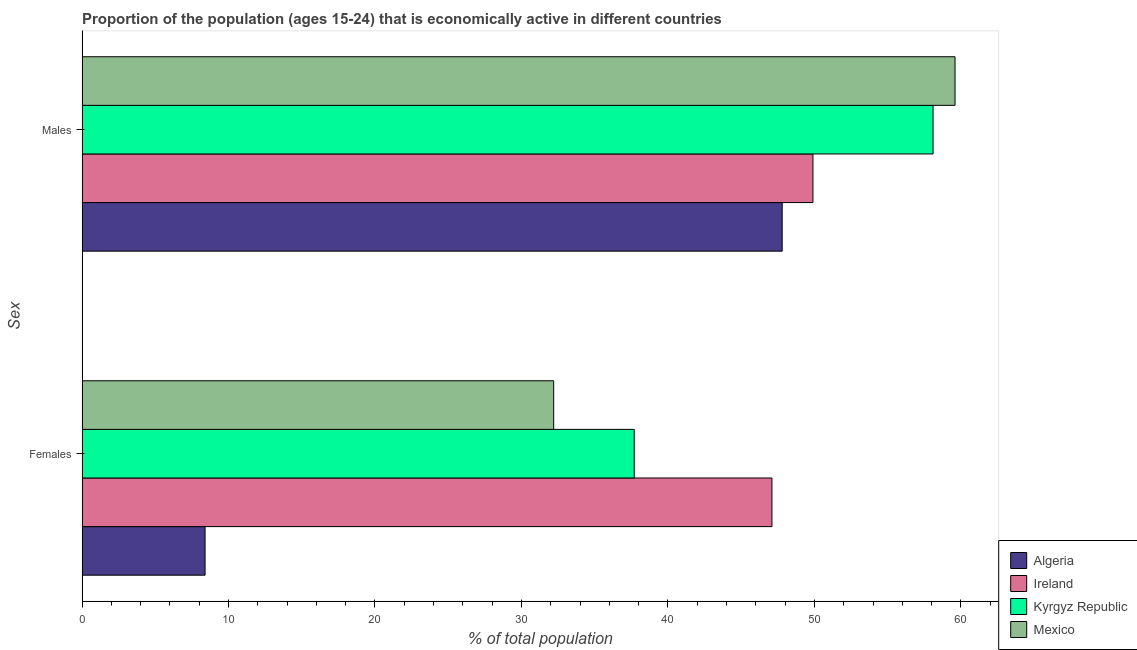How many different coloured bars are there?
Your answer should be very brief. 4. How many groups of bars are there?
Your answer should be compact. 2. Are the number of bars per tick equal to the number of legend labels?
Ensure brevity in your answer.  Yes. Are the number of bars on each tick of the Y-axis equal?
Ensure brevity in your answer.  Yes. How many bars are there on the 1st tick from the bottom?
Provide a short and direct response. 4. What is the label of the 1st group of bars from the top?
Give a very brief answer. Males. What is the percentage of economically active male population in Mexico?
Provide a succinct answer. 59.6. Across all countries, what is the maximum percentage of economically active male population?
Your answer should be compact. 59.6. Across all countries, what is the minimum percentage of economically active male population?
Give a very brief answer. 47.8. In which country was the percentage of economically active male population maximum?
Give a very brief answer. Mexico. In which country was the percentage of economically active female population minimum?
Provide a short and direct response. Algeria. What is the total percentage of economically active female population in the graph?
Offer a very short reply. 125.4. What is the difference between the percentage of economically active female population in Algeria and the percentage of economically active male population in Mexico?
Your answer should be very brief. -51.2. What is the average percentage of economically active female population per country?
Offer a terse response. 31.35. What is the difference between the percentage of economically active female population and percentage of economically active male population in Ireland?
Keep it short and to the point. -2.8. What is the ratio of the percentage of economically active male population in Ireland to that in Kyrgyz Republic?
Keep it short and to the point. 0.86. Is the percentage of economically active female population in Ireland less than that in Algeria?
Provide a short and direct response. No. In how many countries, is the percentage of economically active male population greater than the average percentage of economically active male population taken over all countries?
Ensure brevity in your answer.  2. What does the 4th bar from the top in Males represents?
Keep it short and to the point. Algeria. What does the 3rd bar from the bottom in Females represents?
Give a very brief answer. Kyrgyz Republic. How many bars are there?
Your answer should be compact. 8. Are all the bars in the graph horizontal?
Make the answer very short. Yes. How many countries are there in the graph?
Provide a succinct answer. 4. What is the difference between two consecutive major ticks on the X-axis?
Give a very brief answer. 10. Are the values on the major ticks of X-axis written in scientific E-notation?
Your answer should be very brief. No. Does the graph contain any zero values?
Your answer should be compact. No. Does the graph contain grids?
Your response must be concise. No. How many legend labels are there?
Your answer should be very brief. 4. How are the legend labels stacked?
Keep it short and to the point. Vertical. What is the title of the graph?
Provide a short and direct response. Proportion of the population (ages 15-24) that is economically active in different countries. What is the label or title of the X-axis?
Keep it short and to the point. % of total population. What is the label or title of the Y-axis?
Offer a terse response. Sex. What is the % of total population of Algeria in Females?
Give a very brief answer. 8.4. What is the % of total population of Ireland in Females?
Ensure brevity in your answer.  47.1. What is the % of total population of Kyrgyz Republic in Females?
Make the answer very short. 37.7. What is the % of total population of Mexico in Females?
Offer a terse response. 32.2. What is the % of total population in Algeria in Males?
Provide a succinct answer. 47.8. What is the % of total population in Ireland in Males?
Your answer should be very brief. 49.9. What is the % of total population of Kyrgyz Republic in Males?
Make the answer very short. 58.1. What is the % of total population in Mexico in Males?
Your answer should be very brief. 59.6. Across all Sex, what is the maximum % of total population of Algeria?
Provide a short and direct response. 47.8. Across all Sex, what is the maximum % of total population of Ireland?
Provide a succinct answer. 49.9. Across all Sex, what is the maximum % of total population of Kyrgyz Republic?
Your response must be concise. 58.1. Across all Sex, what is the maximum % of total population of Mexico?
Provide a short and direct response. 59.6. Across all Sex, what is the minimum % of total population of Algeria?
Your response must be concise. 8.4. Across all Sex, what is the minimum % of total population in Ireland?
Make the answer very short. 47.1. Across all Sex, what is the minimum % of total population of Kyrgyz Republic?
Offer a very short reply. 37.7. Across all Sex, what is the minimum % of total population in Mexico?
Make the answer very short. 32.2. What is the total % of total population of Algeria in the graph?
Keep it short and to the point. 56.2. What is the total % of total population in Ireland in the graph?
Provide a succinct answer. 97. What is the total % of total population of Kyrgyz Republic in the graph?
Ensure brevity in your answer.  95.8. What is the total % of total population of Mexico in the graph?
Make the answer very short. 91.8. What is the difference between the % of total population of Algeria in Females and that in Males?
Your response must be concise. -39.4. What is the difference between the % of total population of Ireland in Females and that in Males?
Your response must be concise. -2.8. What is the difference between the % of total population of Kyrgyz Republic in Females and that in Males?
Make the answer very short. -20.4. What is the difference between the % of total population of Mexico in Females and that in Males?
Your answer should be compact. -27.4. What is the difference between the % of total population in Algeria in Females and the % of total population in Ireland in Males?
Your answer should be compact. -41.5. What is the difference between the % of total population of Algeria in Females and the % of total population of Kyrgyz Republic in Males?
Offer a terse response. -49.7. What is the difference between the % of total population in Algeria in Females and the % of total population in Mexico in Males?
Your answer should be compact. -51.2. What is the difference between the % of total population in Ireland in Females and the % of total population in Mexico in Males?
Ensure brevity in your answer.  -12.5. What is the difference between the % of total population in Kyrgyz Republic in Females and the % of total population in Mexico in Males?
Offer a very short reply. -21.9. What is the average % of total population in Algeria per Sex?
Your response must be concise. 28.1. What is the average % of total population of Ireland per Sex?
Provide a succinct answer. 48.5. What is the average % of total population of Kyrgyz Republic per Sex?
Provide a short and direct response. 47.9. What is the average % of total population of Mexico per Sex?
Your answer should be compact. 45.9. What is the difference between the % of total population in Algeria and % of total population in Ireland in Females?
Your response must be concise. -38.7. What is the difference between the % of total population of Algeria and % of total population of Kyrgyz Republic in Females?
Ensure brevity in your answer.  -29.3. What is the difference between the % of total population of Algeria and % of total population of Mexico in Females?
Make the answer very short. -23.8. What is the difference between the % of total population of Ireland and % of total population of Mexico in Females?
Keep it short and to the point. 14.9. What is the difference between the % of total population of Algeria and % of total population of Kyrgyz Republic in Males?
Your response must be concise. -10.3. What is the difference between the % of total population of Ireland and % of total population of Kyrgyz Republic in Males?
Offer a very short reply. -8.2. What is the difference between the % of total population of Ireland and % of total population of Mexico in Males?
Provide a succinct answer. -9.7. What is the ratio of the % of total population in Algeria in Females to that in Males?
Give a very brief answer. 0.18. What is the ratio of the % of total population in Ireland in Females to that in Males?
Provide a succinct answer. 0.94. What is the ratio of the % of total population in Kyrgyz Republic in Females to that in Males?
Provide a short and direct response. 0.65. What is the ratio of the % of total population of Mexico in Females to that in Males?
Your answer should be very brief. 0.54. What is the difference between the highest and the second highest % of total population of Algeria?
Your response must be concise. 39.4. What is the difference between the highest and the second highest % of total population of Kyrgyz Republic?
Ensure brevity in your answer.  20.4. What is the difference between the highest and the second highest % of total population of Mexico?
Your response must be concise. 27.4. What is the difference between the highest and the lowest % of total population in Algeria?
Your answer should be compact. 39.4. What is the difference between the highest and the lowest % of total population of Ireland?
Make the answer very short. 2.8. What is the difference between the highest and the lowest % of total population of Kyrgyz Republic?
Your response must be concise. 20.4. What is the difference between the highest and the lowest % of total population in Mexico?
Ensure brevity in your answer.  27.4. 